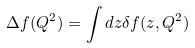Convert formula to latex. <formula><loc_0><loc_0><loc_500><loc_500>\Delta f ( Q ^ { 2 } ) = \int d z \delta f ( z , Q ^ { 2 } )</formula> 